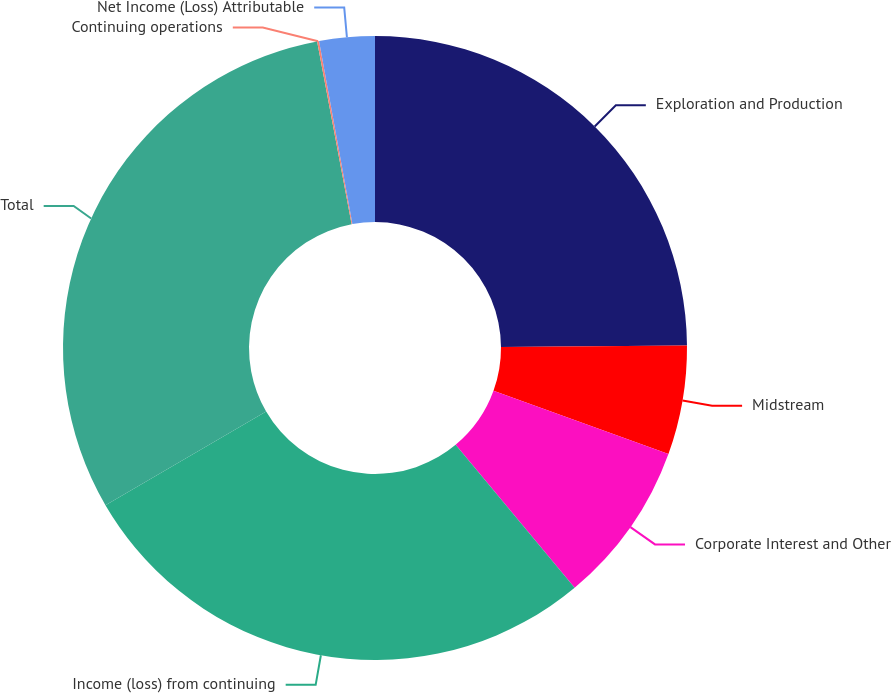Convert chart. <chart><loc_0><loc_0><loc_500><loc_500><pie_chart><fcel>Exploration and Production<fcel>Midstream<fcel>Corporate Interest and Other<fcel>Income (loss) from continuing<fcel>Total<fcel>Continuing operations<fcel>Net Income (Loss) Attributable<nl><fcel>24.87%<fcel>5.65%<fcel>8.43%<fcel>27.65%<fcel>30.43%<fcel>0.1%<fcel>2.87%<nl></chart> 